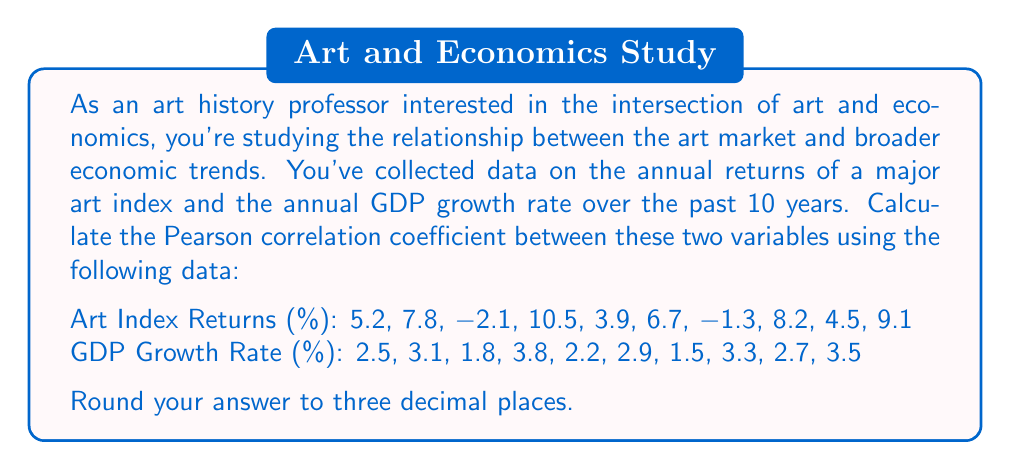Help me with this question. To calculate the Pearson correlation coefficient between the art index returns and GDP growth rate, we'll follow these steps:

1. Calculate the mean of each dataset:
   Let $x$ represent Art Index Returns and $y$ represent GDP Growth Rate.

   $$\bar{x} = \frac{\sum_{i=1}^{n} x_i}{n} = \frac{52.5}{10} = 5.25$$
   $$\bar{y} = \frac{\sum_{i=1}^{n} y_i}{n} = \frac{27.3}{10} = 2.73$$

2. Calculate the difference between each data point and its mean:
   $x_i - \bar{x}$ and $y_i - \bar{y}$ for each pair

3. Multiply these differences: $(x_i - \bar{x})(y_i - \bar{y})$

4. Square the differences: $(x_i - \bar{x})^2$ and $(y_i - \bar{y})^2$

5. Sum up the results from steps 3 and 4:
   $$\sum_{i=1}^{n} (x_i - \bar{x})(y_i - \bar{y}) = 10.9985$$
   $$\sum_{i=1}^{n} (x_i - \bar{x})^2 = 151.7075$$
   $$\sum_{i=1}^{n} (y_i - \bar{y})^2 = 4.3491$$

6. Apply the Pearson correlation coefficient formula:

   $$r = \frac{\sum_{i=1}^{n} (x_i - \bar{x})(y_i - \bar{y})}{\sqrt{\sum_{i=1}^{n} (x_i - \bar{x})^2 \sum_{i=1}^{n} (y_i - \bar{y})^2}}$$

   $$r = \frac{10.9985}{\sqrt{151.7075 \times 4.3491}} = \frac{10.9985}{\sqrt{659.7871}} = \frac{10.9985}{25.6863} = 0.4282$$

7. Round to three decimal places: 0.428

This positive correlation coefficient indicates a moderate positive relationship between art market returns and GDP growth rate.
Answer: 0.428 